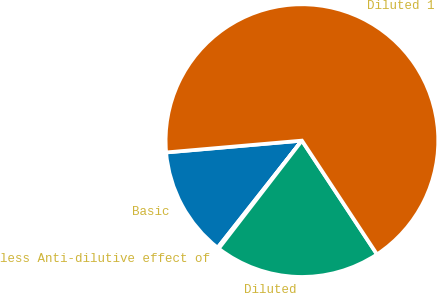Convert chart to OTSL. <chart><loc_0><loc_0><loc_500><loc_500><pie_chart><fcel>Basic<fcel>less Anti-dilutive effect of<fcel>Diluted<fcel>Diluted 1<nl><fcel>13.0%<fcel>0.16%<fcel>19.74%<fcel>67.09%<nl></chart> 